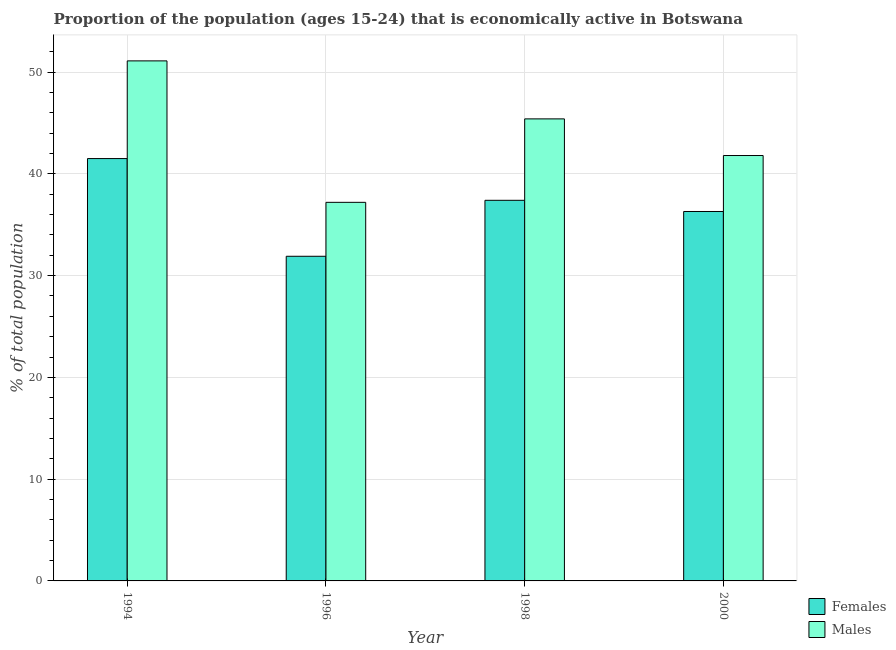How many bars are there on the 3rd tick from the left?
Give a very brief answer. 2. What is the percentage of economically active female population in 1996?
Provide a succinct answer. 31.9. Across all years, what is the maximum percentage of economically active female population?
Your answer should be very brief. 41.5. Across all years, what is the minimum percentage of economically active male population?
Ensure brevity in your answer.  37.2. In which year was the percentage of economically active female population maximum?
Make the answer very short. 1994. In which year was the percentage of economically active female population minimum?
Provide a succinct answer. 1996. What is the total percentage of economically active male population in the graph?
Offer a terse response. 175.5. What is the difference between the percentage of economically active female population in 1998 and that in 2000?
Provide a succinct answer. 1.1. What is the difference between the percentage of economically active male population in 1994 and the percentage of economically active female population in 1998?
Provide a succinct answer. 5.7. What is the average percentage of economically active male population per year?
Give a very brief answer. 43.88. In the year 1998, what is the difference between the percentage of economically active female population and percentage of economically active male population?
Offer a terse response. 0. In how many years, is the percentage of economically active male population greater than 22 %?
Offer a terse response. 4. What is the ratio of the percentage of economically active female population in 1996 to that in 2000?
Your response must be concise. 0.88. Is the difference between the percentage of economically active female population in 1994 and 1998 greater than the difference between the percentage of economically active male population in 1994 and 1998?
Ensure brevity in your answer.  No. What is the difference between the highest and the second highest percentage of economically active female population?
Offer a very short reply. 4.1. What is the difference between the highest and the lowest percentage of economically active female population?
Offer a terse response. 9.6. What does the 2nd bar from the left in 1994 represents?
Provide a short and direct response. Males. What does the 1st bar from the right in 1996 represents?
Provide a short and direct response. Males. Are the values on the major ticks of Y-axis written in scientific E-notation?
Keep it short and to the point. No. Does the graph contain any zero values?
Offer a terse response. No. Does the graph contain grids?
Your answer should be compact. Yes. Where does the legend appear in the graph?
Provide a succinct answer. Bottom right. How many legend labels are there?
Ensure brevity in your answer.  2. What is the title of the graph?
Your answer should be very brief. Proportion of the population (ages 15-24) that is economically active in Botswana. Does "Nitrous oxide emissions" appear as one of the legend labels in the graph?
Offer a terse response. No. What is the label or title of the X-axis?
Provide a short and direct response. Year. What is the label or title of the Y-axis?
Offer a terse response. % of total population. What is the % of total population of Females in 1994?
Your answer should be very brief. 41.5. What is the % of total population in Males in 1994?
Your answer should be very brief. 51.1. What is the % of total population of Females in 1996?
Ensure brevity in your answer.  31.9. What is the % of total population in Males in 1996?
Provide a short and direct response. 37.2. What is the % of total population in Females in 1998?
Offer a very short reply. 37.4. What is the % of total population of Males in 1998?
Keep it short and to the point. 45.4. What is the % of total population in Females in 2000?
Offer a very short reply. 36.3. What is the % of total population in Males in 2000?
Give a very brief answer. 41.8. Across all years, what is the maximum % of total population of Females?
Your response must be concise. 41.5. Across all years, what is the maximum % of total population in Males?
Provide a succinct answer. 51.1. Across all years, what is the minimum % of total population in Females?
Your response must be concise. 31.9. Across all years, what is the minimum % of total population of Males?
Keep it short and to the point. 37.2. What is the total % of total population of Females in the graph?
Keep it short and to the point. 147.1. What is the total % of total population in Males in the graph?
Keep it short and to the point. 175.5. What is the difference between the % of total population in Males in 1994 and that in 1996?
Ensure brevity in your answer.  13.9. What is the difference between the % of total population in Females in 1994 and that in 1998?
Give a very brief answer. 4.1. What is the difference between the % of total population of Females in 1994 and that in 2000?
Give a very brief answer. 5.2. What is the difference between the % of total population of Males in 1994 and that in 2000?
Keep it short and to the point. 9.3. What is the difference between the % of total population of Females in 1996 and that in 1998?
Offer a very short reply. -5.5. What is the difference between the % of total population of Males in 1996 and that in 1998?
Give a very brief answer. -8.2. What is the difference between the % of total population in Females in 1996 and that in 2000?
Ensure brevity in your answer.  -4.4. What is the difference between the % of total population in Males in 1996 and that in 2000?
Keep it short and to the point. -4.6. What is the difference between the % of total population of Females in 1994 and the % of total population of Males in 1996?
Offer a very short reply. 4.3. What is the difference between the % of total population of Females in 1996 and the % of total population of Males in 1998?
Keep it short and to the point. -13.5. What is the average % of total population in Females per year?
Your response must be concise. 36.77. What is the average % of total population in Males per year?
Make the answer very short. 43.88. What is the ratio of the % of total population in Females in 1994 to that in 1996?
Your answer should be compact. 1.3. What is the ratio of the % of total population in Males in 1994 to that in 1996?
Provide a short and direct response. 1.37. What is the ratio of the % of total population of Females in 1994 to that in 1998?
Provide a succinct answer. 1.11. What is the ratio of the % of total population in Males in 1994 to that in 1998?
Keep it short and to the point. 1.13. What is the ratio of the % of total population in Females in 1994 to that in 2000?
Offer a terse response. 1.14. What is the ratio of the % of total population of Males in 1994 to that in 2000?
Give a very brief answer. 1.22. What is the ratio of the % of total population in Females in 1996 to that in 1998?
Offer a very short reply. 0.85. What is the ratio of the % of total population of Males in 1996 to that in 1998?
Your answer should be compact. 0.82. What is the ratio of the % of total population in Females in 1996 to that in 2000?
Your response must be concise. 0.88. What is the ratio of the % of total population in Males in 1996 to that in 2000?
Offer a terse response. 0.89. What is the ratio of the % of total population in Females in 1998 to that in 2000?
Provide a short and direct response. 1.03. What is the ratio of the % of total population of Males in 1998 to that in 2000?
Your response must be concise. 1.09. What is the difference between the highest and the second highest % of total population in Males?
Your answer should be compact. 5.7. What is the difference between the highest and the lowest % of total population of Females?
Offer a terse response. 9.6. 